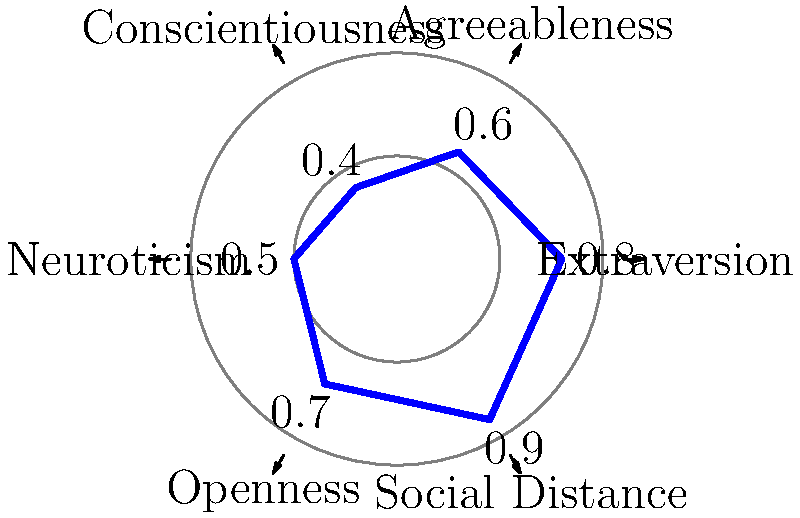In a study investigating the relationship between personality traits and social distance, researchers used a polar plot to represent their findings. The plot shows six dimensions: the Big Five personality traits (Extraversion, Agreeableness, Conscientiousness, Neuroticism, and Openness) and Social Distance. Based on the polar plot, which personality trait appears to have the strongest positive correlation with social distance? To determine which personality trait has the strongest positive correlation with social distance, we need to follow these steps:

1. Understand the polar plot:
   - Each axis represents a dimension (personality trait or social distance).
   - The distance from the center represents the strength or value of each dimension.

2. Identify the Social Distance axis:
   - Social Distance is represented at the 300° position (5 o'clock).

3. Compare the values of personality traits to Social Distance:
   - Extraversion (0°): 0.8
   - Agreeableness (60°): 0.6
   - Conscientiousness (120°): 0.4
   - Neuroticism (180°): 0.5
   - Openness (240°): 0.7
   - Social Distance (300°): 0.9

4. Look for similarities in value and pattern:
   - A positive correlation would be indicated by a trait having a similar value to Social Distance.
   - Extraversion has the closest value (0.8) to Social Distance (0.9).

5. Consider the meaning of the correlation:
   - A positive correlation between Extraversion and Social Distance suggests that as Extraversion increases, Social Distance also increases.

Therefore, based on the polar plot, Extraversion appears to have the strongest positive correlation with social distance.
Answer: Extraversion 